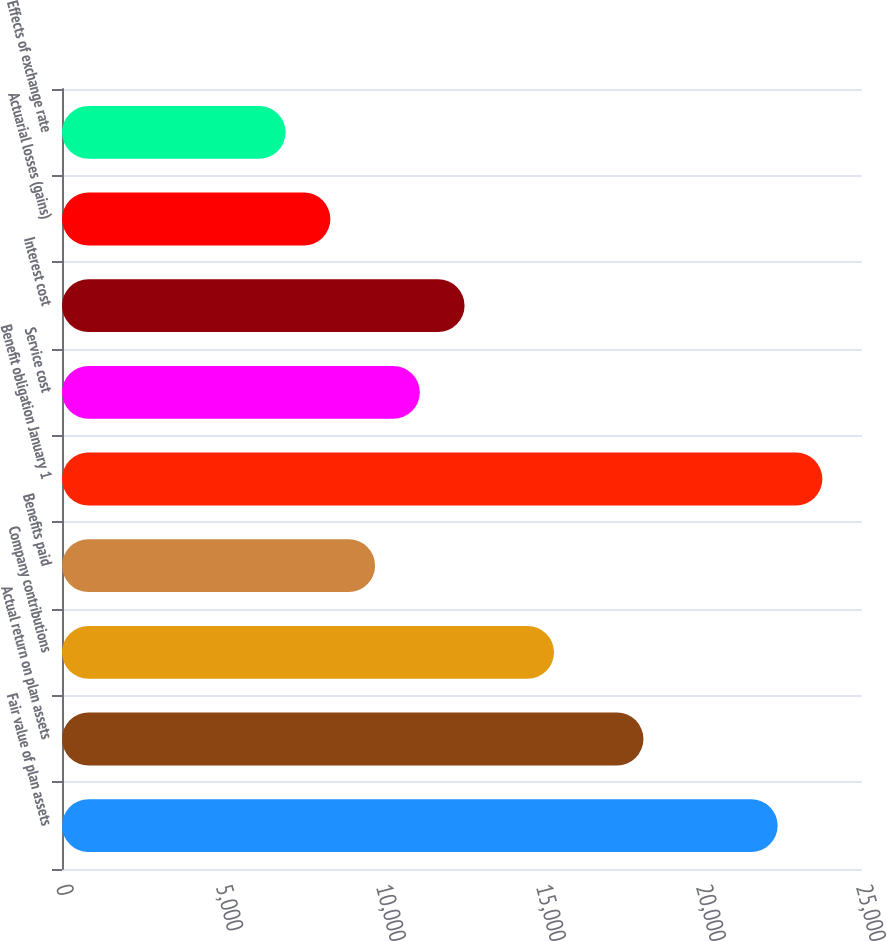Convert chart to OTSL. <chart><loc_0><loc_0><loc_500><loc_500><bar_chart><fcel>Fair value of plan assets<fcel>Actual return on plan assets<fcel>Company contributions<fcel>Benefits paid<fcel>Benefit obligation January 1<fcel>Service cost<fcel>Interest cost<fcel>Actuarial losses (gains)<fcel>Effects of exchange rate<nl><fcel>22364.2<fcel>18171.1<fcel>15375.7<fcel>9784.9<fcel>23761.9<fcel>11182.6<fcel>12580.3<fcel>8387.2<fcel>6989.5<nl></chart> 